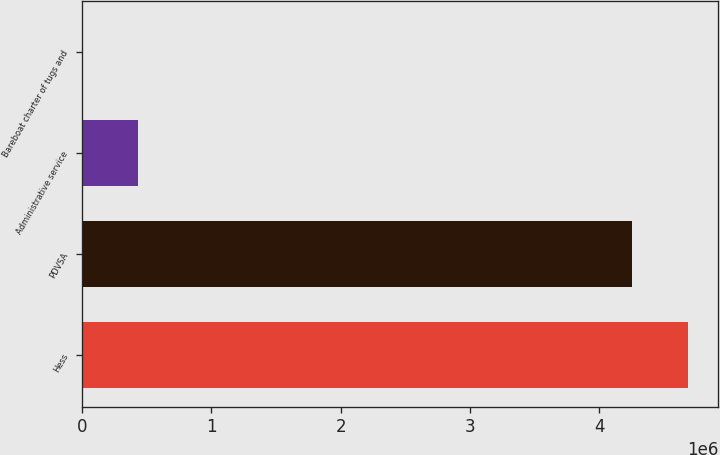Convert chart to OTSL. <chart><loc_0><loc_0><loc_500><loc_500><bar_chart><fcel>Hess<fcel>PDVSA<fcel>Administrative service<fcel>Bareboat charter of tugs and<nl><fcel>4.68516e+06<fcel>4.25476e+06<fcel>433556<fcel>3161<nl></chart> 